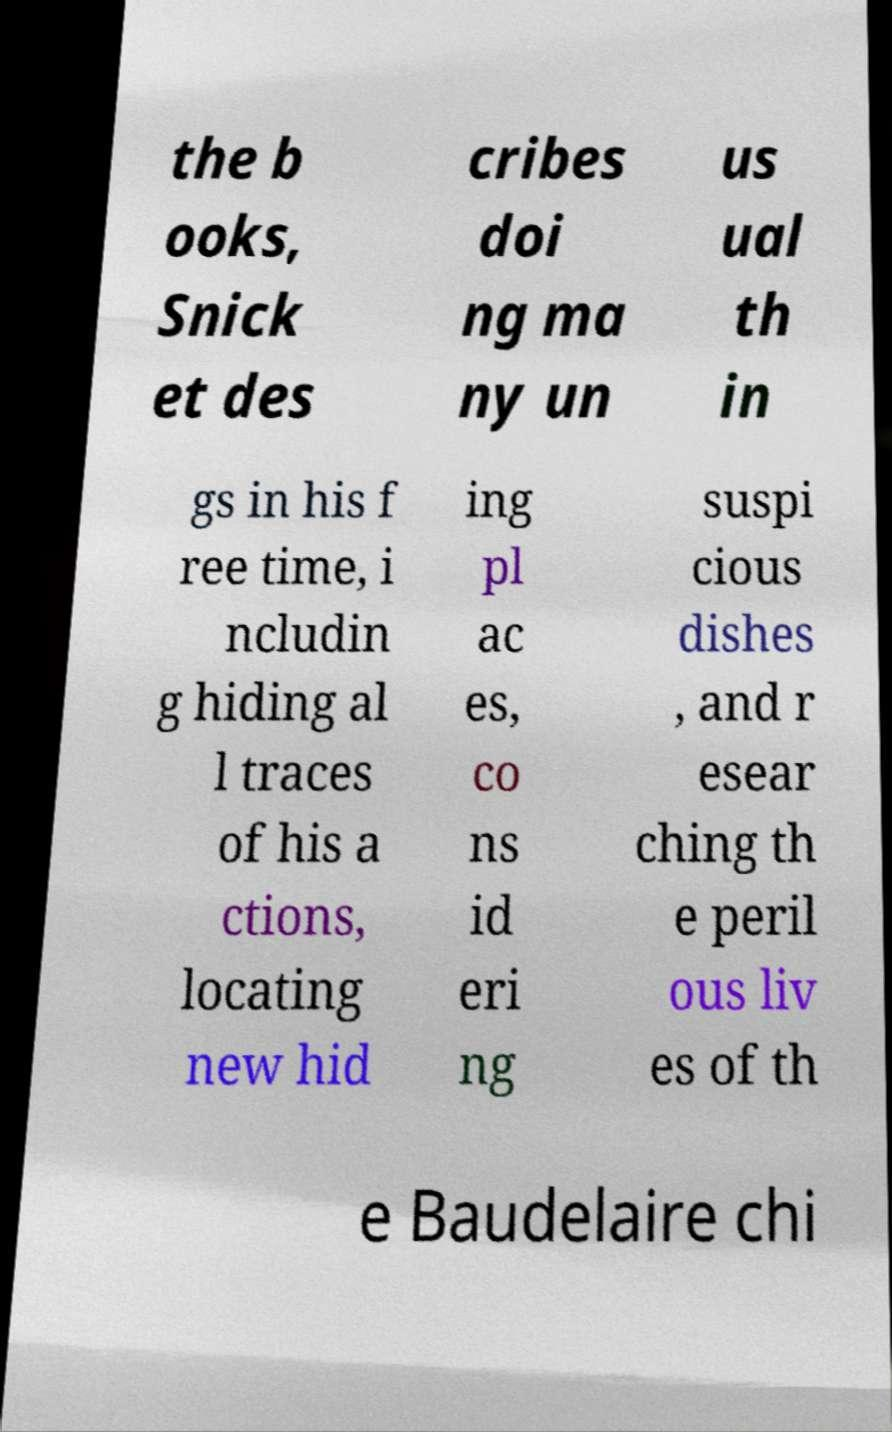Can you read and provide the text displayed in the image?This photo seems to have some interesting text. Can you extract and type it out for me? the b ooks, Snick et des cribes doi ng ma ny un us ual th in gs in his f ree time, i ncludin g hiding al l traces of his a ctions, locating new hid ing pl ac es, co ns id eri ng suspi cious dishes , and r esear ching th e peril ous liv es of th e Baudelaire chi 